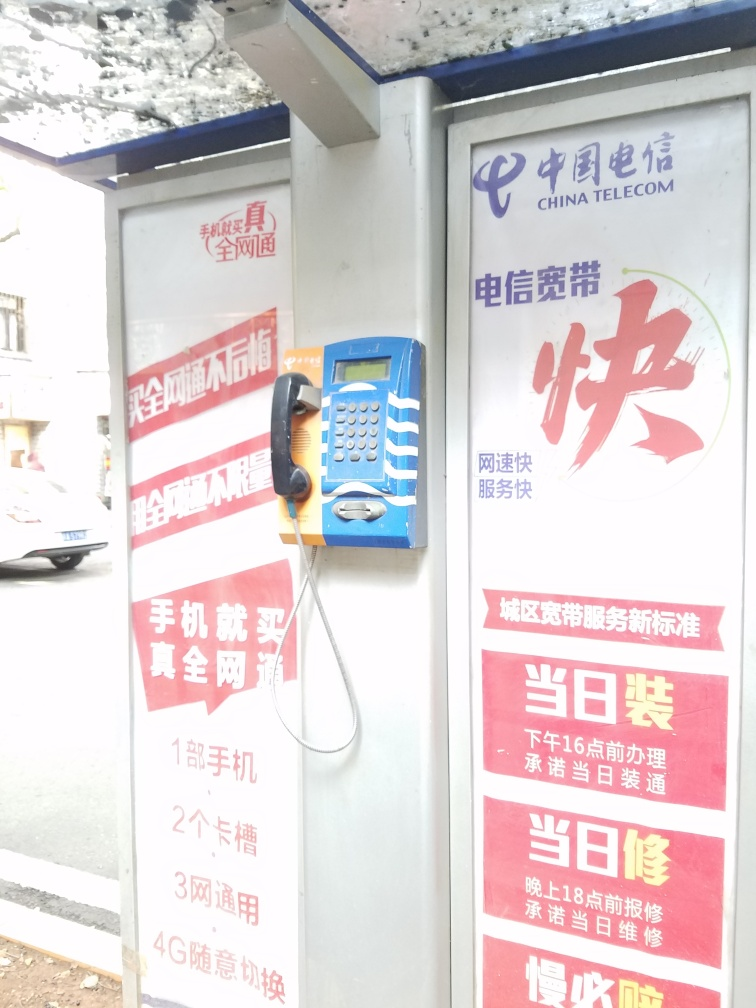What is the cultural significance of a telephone booth in today's society? Even as mobile phones have become ubiquitous, public telephone booths hold cultural significance as relics of a past era of communication. They symbolize the history of telecommunication and serve as important public resources during emergencies or for those without other means to communicate. In some places, they are being repurposed as Wi-Fi hotspots, charging stations, or tourist attractions, reflecting society's adaptive reuse of technology. 